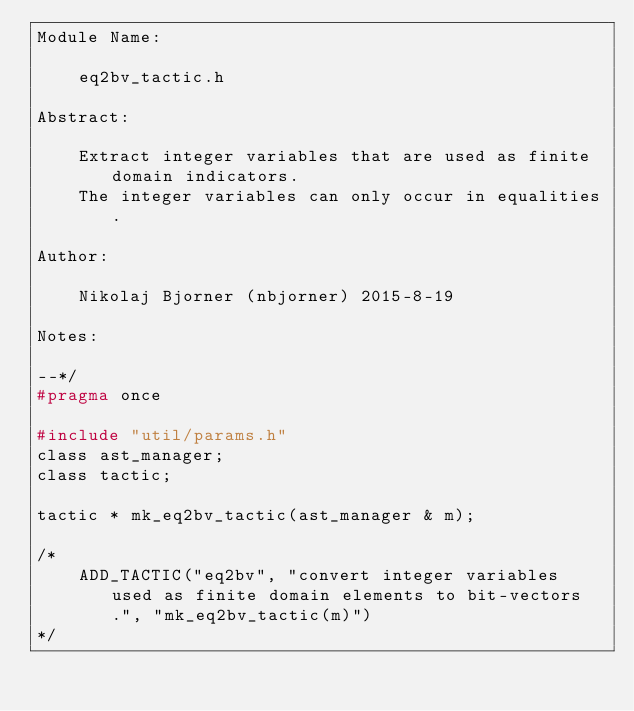Convert code to text. <code><loc_0><loc_0><loc_500><loc_500><_C_>Module Name:

    eq2bv_tactic.h

Abstract:

    Extract integer variables that are used as finite domain indicators.
    The integer variables can only occur in equalities.

Author:

    Nikolaj Bjorner (nbjorner) 2015-8-19

Notes:

--*/
#pragma once

#include "util/params.h"
class ast_manager;
class tactic;

tactic * mk_eq2bv_tactic(ast_manager & m);

/*
    ADD_TACTIC("eq2bv", "convert integer variables used as finite domain elements to bit-vectors.", "mk_eq2bv_tactic(m)")
*/


</code> 